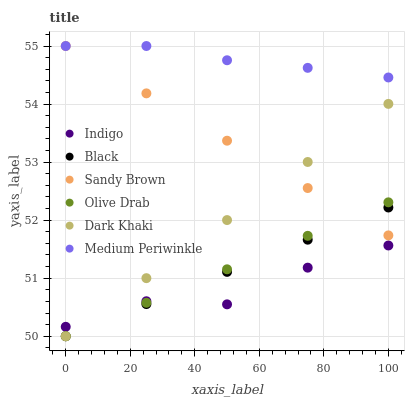Does Indigo have the minimum area under the curve?
Answer yes or no. Yes. Does Medium Periwinkle have the maximum area under the curve?
Answer yes or no. Yes. Does Dark Khaki have the minimum area under the curve?
Answer yes or no. No. Does Dark Khaki have the maximum area under the curve?
Answer yes or no. No. Is Dark Khaki the smoothest?
Answer yes or no. Yes. Is Indigo the roughest?
Answer yes or no. Yes. Is Medium Periwinkle the smoothest?
Answer yes or no. No. Is Medium Periwinkle the roughest?
Answer yes or no. No. Does Dark Khaki have the lowest value?
Answer yes or no. Yes. Does Medium Periwinkle have the lowest value?
Answer yes or no. No. Does Sandy Brown have the highest value?
Answer yes or no. Yes. Does Dark Khaki have the highest value?
Answer yes or no. No. Is Dark Khaki less than Medium Periwinkle?
Answer yes or no. Yes. Is Medium Periwinkle greater than Black?
Answer yes or no. Yes. Does Indigo intersect Dark Khaki?
Answer yes or no. Yes. Is Indigo less than Dark Khaki?
Answer yes or no. No. Is Indigo greater than Dark Khaki?
Answer yes or no. No. Does Dark Khaki intersect Medium Periwinkle?
Answer yes or no. No. 